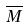<formula> <loc_0><loc_0><loc_500><loc_500>\overline { M }</formula> 